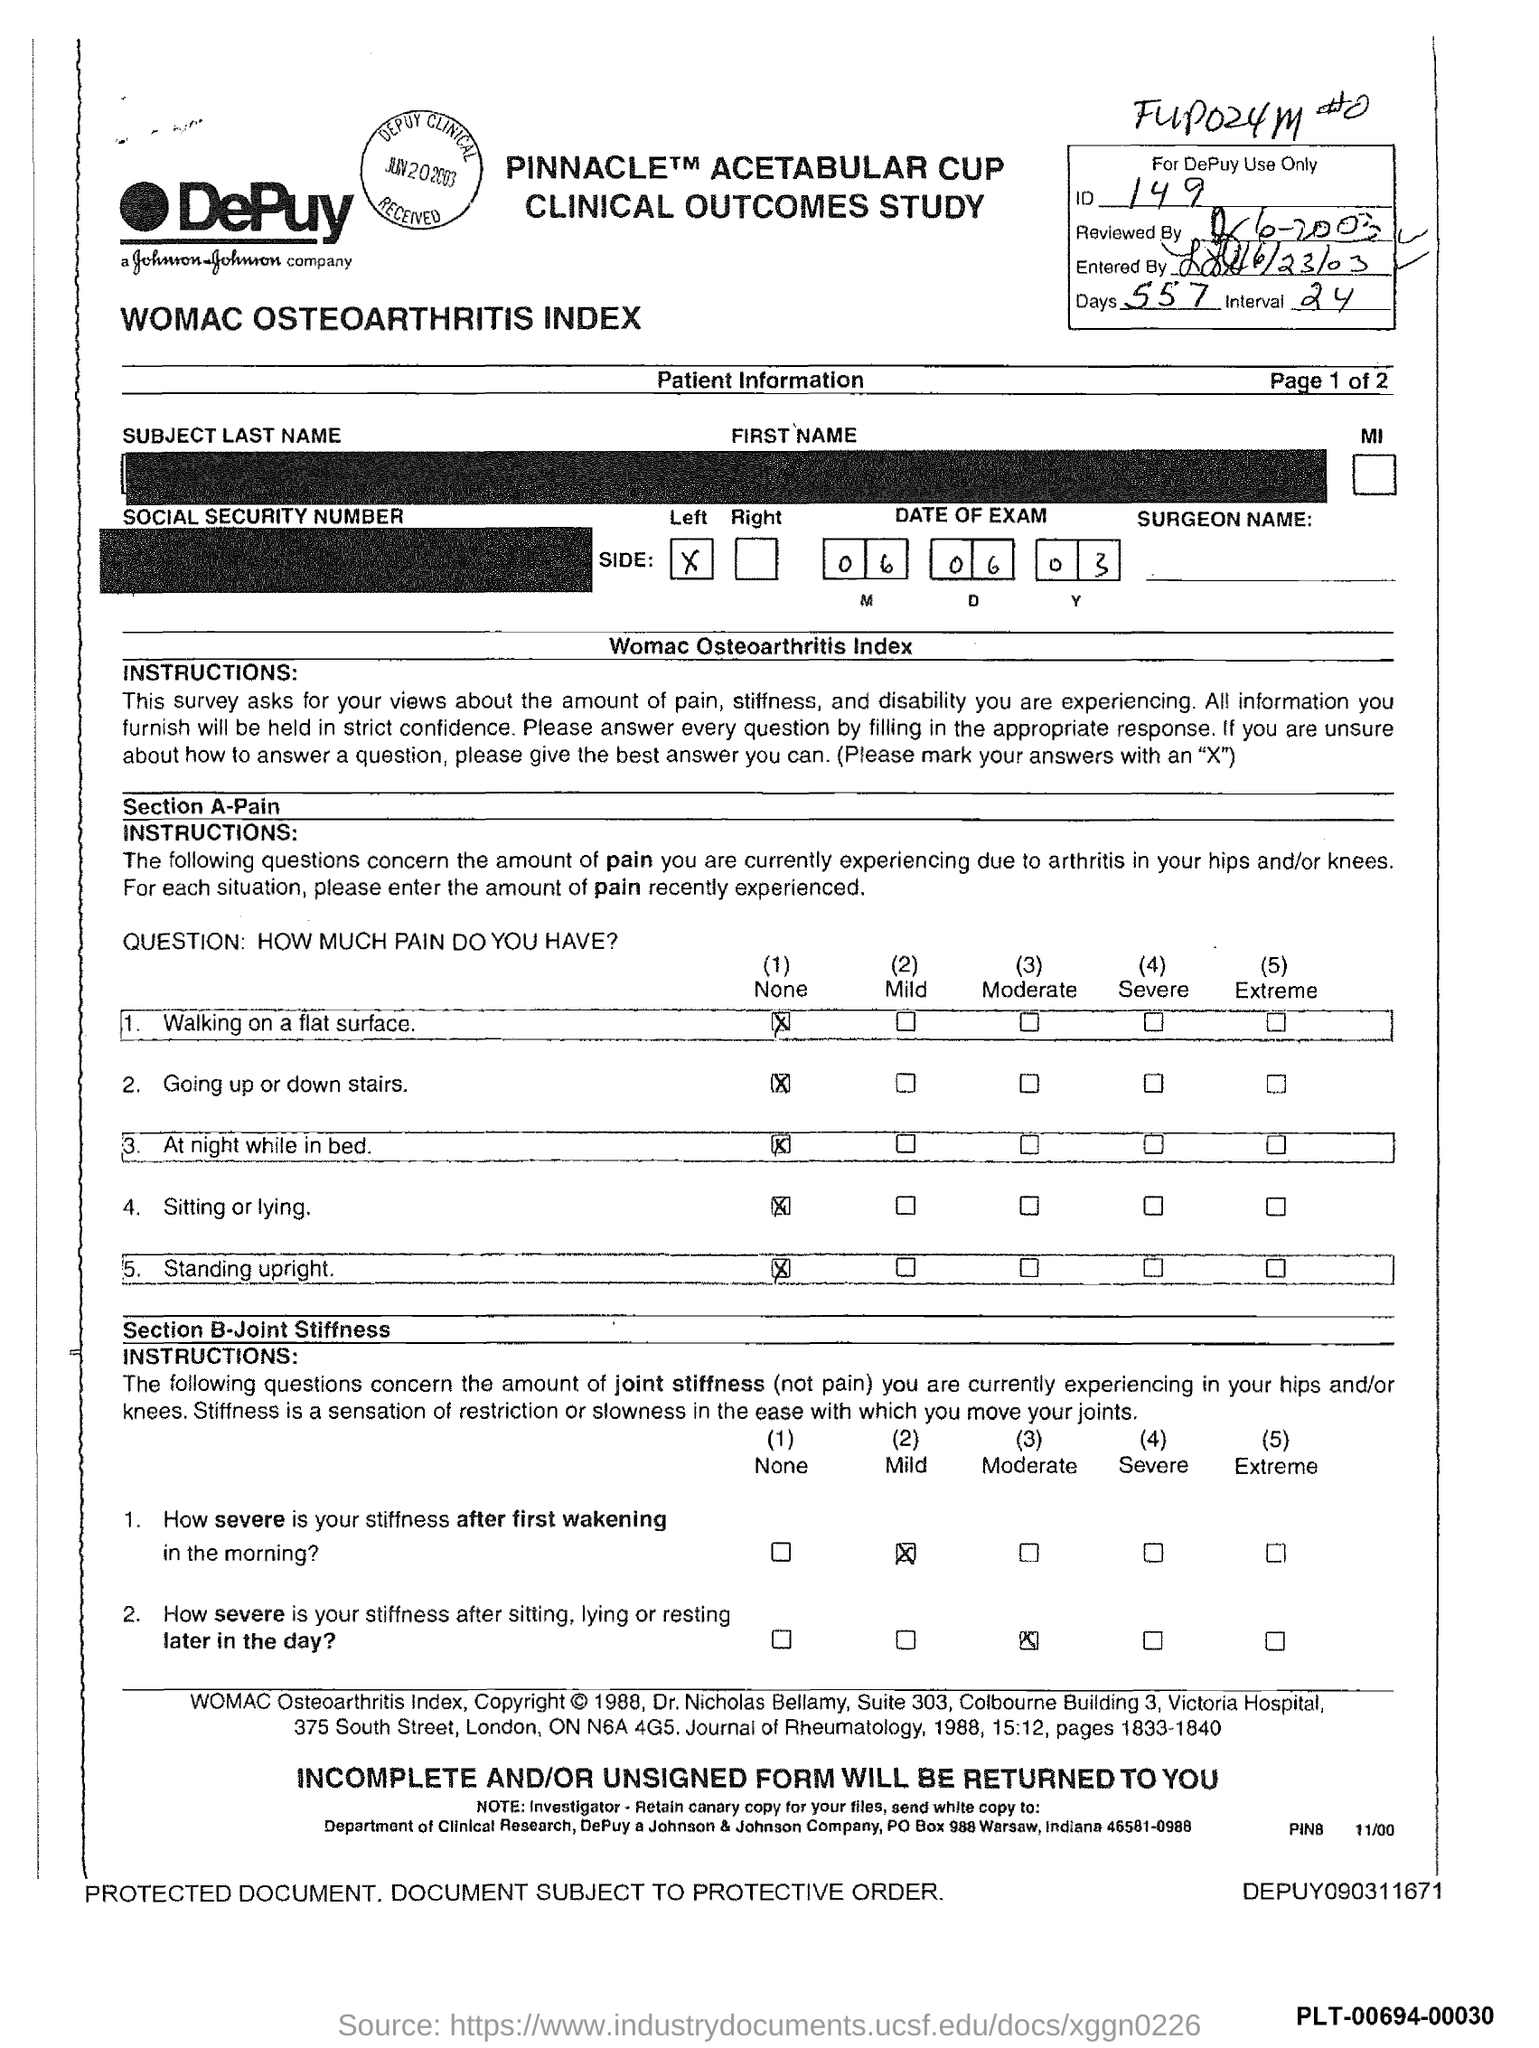What is the ID mentioned in the form?
Make the answer very short. 149. What is the no of days given in the form?
Offer a very short reply. 557. What is the interval mentioned in the form?
Ensure brevity in your answer.  24. What is the date of the exam given in the form?
Provide a short and direct response. 06 06 03. 